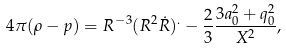Convert formula to latex. <formula><loc_0><loc_0><loc_500><loc_500>4 \pi ( \rho - p ) = R ^ { - 3 } ( R ^ { 2 } \dot { R } ) ^ { . } - \frac { 2 } { 3 } \frac { 3 a _ { 0 } ^ { 2 } + q _ { 0 } ^ { 2 } } { X ^ { 2 } } ,</formula> 